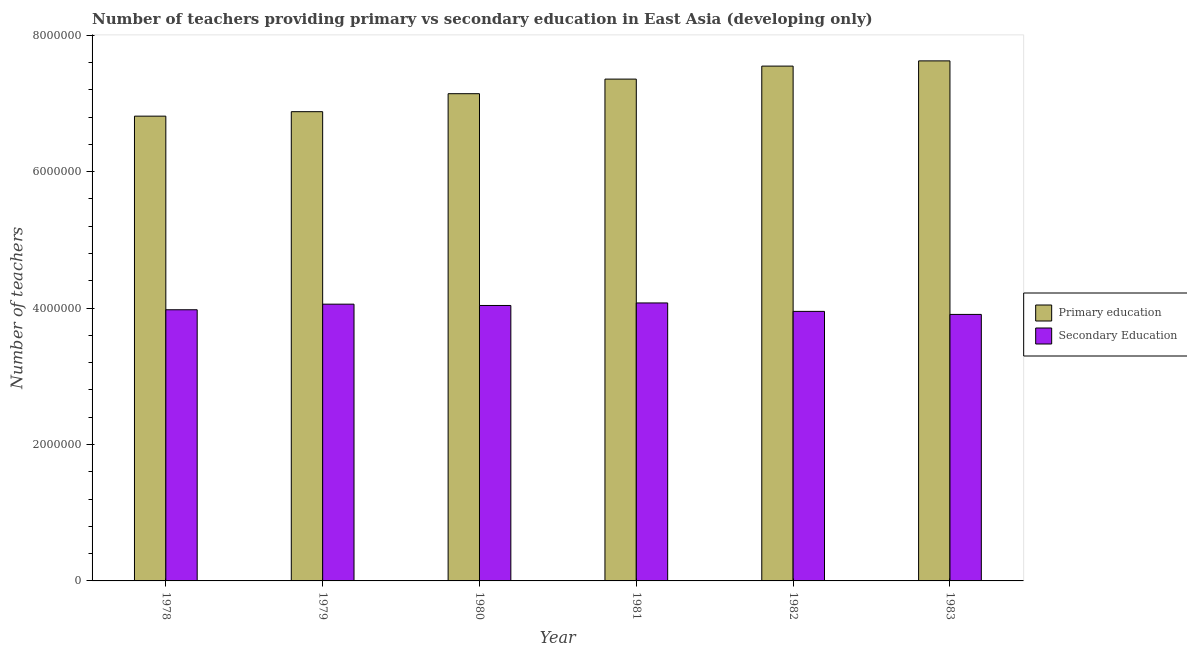How many different coloured bars are there?
Your answer should be very brief. 2. How many groups of bars are there?
Keep it short and to the point. 6. Are the number of bars per tick equal to the number of legend labels?
Offer a terse response. Yes. Are the number of bars on each tick of the X-axis equal?
Ensure brevity in your answer.  Yes. How many bars are there on the 6th tick from the left?
Ensure brevity in your answer.  2. In how many cases, is the number of bars for a given year not equal to the number of legend labels?
Provide a short and direct response. 0. What is the number of secondary teachers in 1982?
Provide a succinct answer. 3.95e+06. Across all years, what is the maximum number of secondary teachers?
Your answer should be compact. 4.07e+06. Across all years, what is the minimum number of primary teachers?
Your response must be concise. 6.81e+06. In which year was the number of primary teachers minimum?
Your response must be concise. 1978. What is the total number of primary teachers in the graph?
Provide a short and direct response. 4.34e+07. What is the difference between the number of primary teachers in 1982 and that in 1983?
Your answer should be very brief. -7.65e+04. What is the difference between the number of secondary teachers in 1979 and the number of primary teachers in 1983?
Give a very brief answer. 1.50e+05. What is the average number of primary teachers per year?
Provide a short and direct response. 7.23e+06. What is the ratio of the number of primary teachers in 1980 to that in 1982?
Your answer should be very brief. 0.95. Is the difference between the number of primary teachers in 1979 and 1983 greater than the difference between the number of secondary teachers in 1979 and 1983?
Provide a succinct answer. No. What is the difference between the highest and the second highest number of primary teachers?
Your answer should be compact. 7.65e+04. What is the difference between the highest and the lowest number of secondary teachers?
Give a very brief answer. 1.68e+05. In how many years, is the number of secondary teachers greater than the average number of secondary teachers taken over all years?
Provide a short and direct response. 3. Is the sum of the number of secondary teachers in 1981 and 1983 greater than the maximum number of primary teachers across all years?
Your answer should be very brief. Yes. What does the 1st bar from the right in 1982 represents?
Provide a succinct answer. Secondary Education. Are all the bars in the graph horizontal?
Offer a terse response. No. Are the values on the major ticks of Y-axis written in scientific E-notation?
Your answer should be very brief. No. Does the graph contain grids?
Keep it short and to the point. No. What is the title of the graph?
Ensure brevity in your answer.  Number of teachers providing primary vs secondary education in East Asia (developing only). Does "Secondary education" appear as one of the legend labels in the graph?
Provide a short and direct response. No. What is the label or title of the Y-axis?
Give a very brief answer. Number of teachers. What is the Number of teachers in Primary education in 1978?
Offer a terse response. 6.81e+06. What is the Number of teachers of Secondary Education in 1978?
Provide a short and direct response. 3.97e+06. What is the Number of teachers of Primary education in 1979?
Keep it short and to the point. 6.88e+06. What is the Number of teachers in Secondary Education in 1979?
Offer a terse response. 4.06e+06. What is the Number of teachers of Primary education in 1980?
Offer a terse response. 7.14e+06. What is the Number of teachers in Secondary Education in 1980?
Make the answer very short. 4.04e+06. What is the Number of teachers in Primary education in 1981?
Offer a terse response. 7.36e+06. What is the Number of teachers in Secondary Education in 1981?
Provide a short and direct response. 4.07e+06. What is the Number of teachers of Primary education in 1982?
Keep it short and to the point. 7.55e+06. What is the Number of teachers of Secondary Education in 1982?
Offer a very short reply. 3.95e+06. What is the Number of teachers in Primary education in 1983?
Offer a terse response. 7.62e+06. What is the Number of teachers in Secondary Education in 1983?
Your answer should be compact. 3.91e+06. Across all years, what is the maximum Number of teachers of Primary education?
Your answer should be very brief. 7.62e+06. Across all years, what is the maximum Number of teachers in Secondary Education?
Your answer should be very brief. 4.07e+06. Across all years, what is the minimum Number of teachers of Primary education?
Ensure brevity in your answer.  6.81e+06. Across all years, what is the minimum Number of teachers of Secondary Education?
Make the answer very short. 3.91e+06. What is the total Number of teachers of Primary education in the graph?
Provide a succinct answer. 4.34e+07. What is the total Number of teachers of Secondary Education in the graph?
Offer a very short reply. 2.40e+07. What is the difference between the Number of teachers of Primary education in 1978 and that in 1979?
Ensure brevity in your answer.  -6.55e+04. What is the difference between the Number of teachers in Secondary Education in 1978 and that in 1979?
Your response must be concise. -8.20e+04. What is the difference between the Number of teachers of Primary education in 1978 and that in 1980?
Your answer should be compact. -3.29e+05. What is the difference between the Number of teachers of Secondary Education in 1978 and that in 1980?
Your answer should be very brief. -6.27e+04. What is the difference between the Number of teachers of Primary education in 1978 and that in 1981?
Offer a terse response. -5.43e+05. What is the difference between the Number of teachers in Secondary Education in 1978 and that in 1981?
Give a very brief answer. -9.98e+04. What is the difference between the Number of teachers in Primary education in 1978 and that in 1982?
Provide a short and direct response. -7.34e+05. What is the difference between the Number of teachers of Secondary Education in 1978 and that in 1982?
Offer a very short reply. 2.39e+04. What is the difference between the Number of teachers of Primary education in 1978 and that in 1983?
Keep it short and to the point. -8.10e+05. What is the difference between the Number of teachers in Secondary Education in 1978 and that in 1983?
Ensure brevity in your answer.  6.83e+04. What is the difference between the Number of teachers of Primary education in 1979 and that in 1980?
Provide a short and direct response. -2.64e+05. What is the difference between the Number of teachers of Secondary Education in 1979 and that in 1980?
Provide a succinct answer. 1.93e+04. What is the difference between the Number of teachers in Primary education in 1979 and that in 1981?
Give a very brief answer. -4.77e+05. What is the difference between the Number of teachers in Secondary Education in 1979 and that in 1981?
Offer a very short reply. -1.79e+04. What is the difference between the Number of teachers of Primary education in 1979 and that in 1982?
Offer a very short reply. -6.68e+05. What is the difference between the Number of teachers of Secondary Education in 1979 and that in 1982?
Keep it short and to the point. 1.06e+05. What is the difference between the Number of teachers of Primary education in 1979 and that in 1983?
Offer a terse response. -7.45e+05. What is the difference between the Number of teachers of Secondary Education in 1979 and that in 1983?
Make the answer very short. 1.50e+05. What is the difference between the Number of teachers in Primary education in 1980 and that in 1981?
Keep it short and to the point. -2.14e+05. What is the difference between the Number of teachers of Secondary Education in 1980 and that in 1981?
Keep it short and to the point. -3.71e+04. What is the difference between the Number of teachers of Primary education in 1980 and that in 1982?
Your response must be concise. -4.05e+05. What is the difference between the Number of teachers in Secondary Education in 1980 and that in 1982?
Offer a terse response. 8.66e+04. What is the difference between the Number of teachers of Primary education in 1980 and that in 1983?
Your answer should be very brief. -4.81e+05. What is the difference between the Number of teachers in Secondary Education in 1980 and that in 1983?
Keep it short and to the point. 1.31e+05. What is the difference between the Number of teachers in Primary education in 1981 and that in 1982?
Give a very brief answer. -1.91e+05. What is the difference between the Number of teachers in Secondary Education in 1981 and that in 1982?
Ensure brevity in your answer.  1.24e+05. What is the difference between the Number of teachers in Primary education in 1981 and that in 1983?
Offer a very short reply. -2.67e+05. What is the difference between the Number of teachers of Secondary Education in 1981 and that in 1983?
Your answer should be compact. 1.68e+05. What is the difference between the Number of teachers of Primary education in 1982 and that in 1983?
Offer a terse response. -7.65e+04. What is the difference between the Number of teachers in Secondary Education in 1982 and that in 1983?
Offer a very short reply. 4.44e+04. What is the difference between the Number of teachers in Primary education in 1978 and the Number of teachers in Secondary Education in 1979?
Provide a succinct answer. 2.76e+06. What is the difference between the Number of teachers in Primary education in 1978 and the Number of teachers in Secondary Education in 1980?
Offer a terse response. 2.78e+06. What is the difference between the Number of teachers in Primary education in 1978 and the Number of teachers in Secondary Education in 1981?
Make the answer very short. 2.74e+06. What is the difference between the Number of teachers in Primary education in 1978 and the Number of teachers in Secondary Education in 1982?
Provide a short and direct response. 2.86e+06. What is the difference between the Number of teachers in Primary education in 1978 and the Number of teachers in Secondary Education in 1983?
Provide a short and direct response. 2.91e+06. What is the difference between the Number of teachers of Primary education in 1979 and the Number of teachers of Secondary Education in 1980?
Offer a terse response. 2.84e+06. What is the difference between the Number of teachers of Primary education in 1979 and the Number of teachers of Secondary Education in 1981?
Keep it short and to the point. 2.80e+06. What is the difference between the Number of teachers of Primary education in 1979 and the Number of teachers of Secondary Education in 1982?
Make the answer very short. 2.93e+06. What is the difference between the Number of teachers of Primary education in 1979 and the Number of teachers of Secondary Education in 1983?
Make the answer very short. 2.97e+06. What is the difference between the Number of teachers of Primary education in 1980 and the Number of teachers of Secondary Education in 1981?
Offer a very short reply. 3.07e+06. What is the difference between the Number of teachers of Primary education in 1980 and the Number of teachers of Secondary Education in 1982?
Offer a very short reply. 3.19e+06. What is the difference between the Number of teachers in Primary education in 1980 and the Number of teachers in Secondary Education in 1983?
Keep it short and to the point. 3.24e+06. What is the difference between the Number of teachers in Primary education in 1981 and the Number of teachers in Secondary Education in 1982?
Make the answer very short. 3.40e+06. What is the difference between the Number of teachers of Primary education in 1981 and the Number of teachers of Secondary Education in 1983?
Offer a terse response. 3.45e+06. What is the difference between the Number of teachers in Primary education in 1982 and the Number of teachers in Secondary Education in 1983?
Provide a succinct answer. 3.64e+06. What is the average Number of teachers of Primary education per year?
Your answer should be compact. 7.23e+06. What is the average Number of teachers in Secondary Education per year?
Your response must be concise. 4.00e+06. In the year 1978, what is the difference between the Number of teachers in Primary education and Number of teachers in Secondary Education?
Provide a succinct answer. 2.84e+06. In the year 1979, what is the difference between the Number of teachers in Primary education and Number of teachers in Secondary Education?
Provide a short and direct response. 2.82e+06. In the year 1980, what is the difference between the Number of teachers of Primary education and Number of teachers of Secondary Education?
Offer a terse response. 3.10e+06. In the year 1981, what is the difference between the Number of teachers in Primary education and Number of teachers in Secondary Education?
Ensure brevity in your answer.  3.28e+06. In the year 1982, what is the difference between the Number of teachers in Primary education and Number of teachers in Secondary Education?
Keep it short and to the point. 3.60e+06. In the year 1983, what is the difference between the Number of teachers in Primary education and Number of teachers in Secondary Education?
Ensure brevity in your answer.  3.72e+06. What is the ratio of the Number of teachers in Secondary Education in 1978 to that in 1979?
Ensure brevity in your answer.  0.98. What is the ratio of the Number of teachers in Primary education in 1978 to that in 1980?
Make the answer very short. 0.95. What is the ratio of the Number of teachers of Secondary Education in 1978 to that in 1980?
Make the answer very short. 0.98. What is the ratio of the Number of teachers of Primary education in 1978 to that in 1981?
Your answer should be compact. 0.93. What is the ratio of the Number of teachers in Secondary Education in 1978 to that in 1981?
Ensure brevity in your answer.  0.98. What is the ratio of the Number of teachers of Primary education in 1978 to that in 1982?
Your response must be concise. 0.9. What is the ratio of the Number of teachers of Primary education in 1978 to that in 1983?
Give a very brief answer. 0.89. What is the ratio of the Number of teachers of Secondary Education in 1978 to that in 1983?
Offer a terse response. 1.02. What is the ratio of the Number of teachers in Primary education in 1979 to that in 1980?
Offer a terse response. 0.96. What is the ratio of the Number of teachers in Secondary Education in 1979 to that in 1980?
Provide a succinct answer. 1. What is the ratio of the Number of teachers of Primary education in 1979 to that in 1981?
Make the answer very short. 0.94. What is the ratio of the Number of teachers in Primary education in 1979 to that in 1982?
Your answer should be compact. 0.91. What is the ratio of the Number of teachers of Secondary Education in 1979 to that in 1982?
Keep it short and to the point. 1.03. What is the ratio of the Number of teachers of Primary education in 1979 to that in 1983?
Your answer should be compact. 0.9. What is the ratio of the Number of teachers in Primary education in 1980 to that in 1981?
Your answer should be compact. 0.97. What is the ratio of the Number of teachers of Secondary Education in 1980 to that in 1981?
Give a very brief answer. 0.99. What is the ratio of the Number of teachers in Primary education in 1980 to that in 1982?
Your response must be concise. 0.95. What is the ratio of the Number of teachers in Secondary Education in 1980 to that in 1982?
Your response must be concise. 1.02. What is the ratio of the Number of teachers in Primary education in 1980 to that in 1983?
Make the answer very short. 0.94. What is the ratio of the Number of teachers in Secondary Education in 1980 to that in 1983?
Give a very brief answer. 1.03. What is the ratio of the Number of teachers of Primary education in 1981 to that in 1982?
Offer a terse response. 0.97. What is the ratio of the Number of teachers in Secondary Education in 1981 to that in 1982?
Provide a succinct answer. 1.03. What is the ratio of the Number of teachers in Secondary Education in 1981 to that in 1983?
Your response must be concise. 1.04. What is the ratio of the Number of teachers of Secondary Education in 1982 to that in 1983?
Your answer should be compact. 1.01. What is the difference between the highest and the second highest Number of teachers in Primary education?
Make the answer very short. 7.65e+04. What is the difference between the highest and the second highest Number of teachers of Secondary Education?
Your answer should be compact. 1.79e+04. What is the difference between the highest and the lowest Number of teachers of Primary education?
Offer a very short reply. 8.10e+05. What is the difference between the highest and the lowest Number of teachers of Secondary Education?
Offer a terse response. 1.68e+05. 